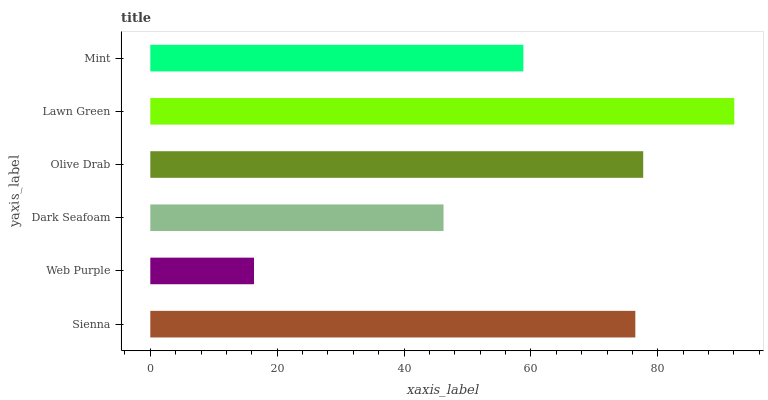Is Web Purple the minimum?
Answer yes or no. Yes. Is Lawn Green the maximum?
Answer yes or no. Yes. Is Dark Seafoam the minimum?
Answer yes or no. No. Is Dark Seafoam the maximum?
Answer yes or no. No. Is Dark Seafoam greater than Web Purple?
Answer yes or no. Yes. Is Web Purple less than Dark Seafoam?
Answer yes or no. Yes. Is Web Purple greater than Dark Seafoam?
Answer yes or no. No. Is Dark Seafoam less than Web Purple?
Answer yes or no. No. Is Sienna the high median?
Answer yes or no. Yes. Is Mint the low median?
Answer yes or no. Yes. Is Olive Drab the high median?
Answer yes or no. No. Is Sienna the low median?
Answer yes or no. No. 